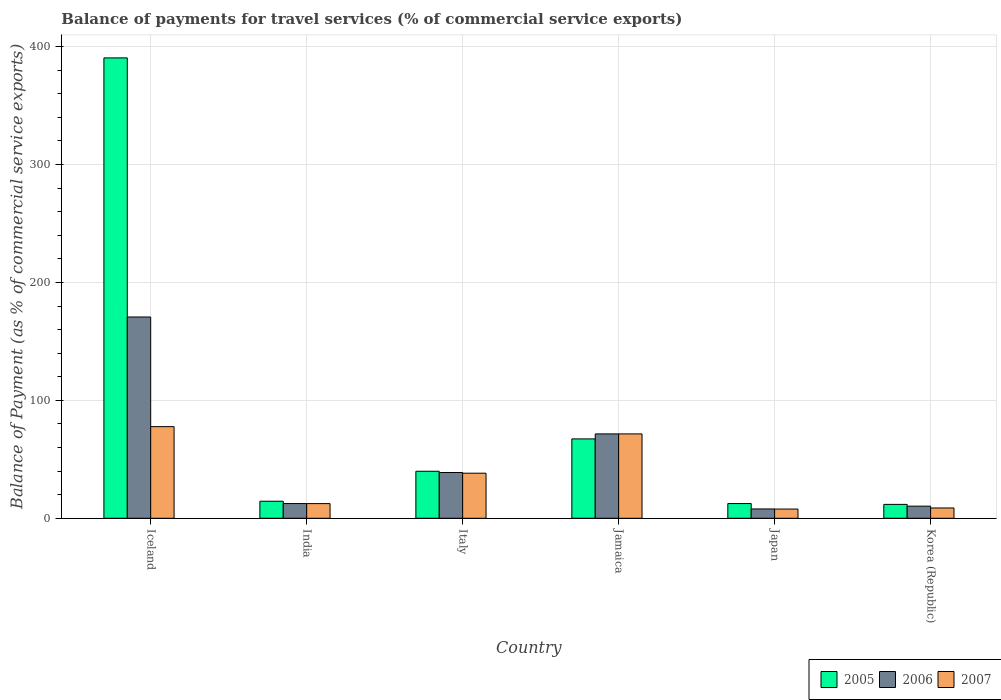How many different coloured bars are there?
Give a very brief answer. 3. Are the number of bars per tick equal to the number of legend labels?
Ensure brevity in your answer.  Yes. How many bars are there on the 2nd tick from the left?
Offer a terse response. 3. What is the label of the 3rd group of bars from the left?
Ensure brevity in your answer.  Italy. In how many cases, is the number of bars for a given country not equal to the number of legend labels?
Provide a succinct answer. 0. What is the balance of payments for travel services in 2005 in Italy?
Give a very brief answer. 39.87. Across all countries, what is the maximum balance of payments for travel services in 2005?
Your response must be concise. 390.42. Across all countries, what is the minimum balance of payments for travel services in 2007?
Your answer should be very brief. 7.82. In which country was the balance of payments for travel services in 2005 maximum?
Your answer should be very brief. Iceland. What is the total balance of payments for travel services in 2006 in the graph?
Provide a succinct answer. 311.73. What is the difference between the balance of payments for travel services in 2007 in Italy and that in Korea (Republic)?
Keep it short and to the point. 29.49. What is the difference between the balance of payments for travel services in 2006 in Iceland and the balance of payments for travel services in 2005 in Japan?
Ensure brevity in your answer.  158.22. What is the average balance of payments for travel services in 2005 per country?
Provide a short and direct response. 89.38. What is the difference between the balance of payments for travel services of/in 2005 and balance of payments for travel services of/in 2007 in Korea (Republic)?
Your answer should be very brief. 3.04. In how many countries, is the balance of payments for travel services in 2007 greater than 360 %?
Offer a terse response. 0. What is the ratio of the balance of payments for travel services in 2005 in India to that in Korea (Republic)?
Your answer should be compact. 1.23. What is the difference between the highest and the second highest balance of payments for travel services in 2005?
Offer a very short reply. -323.11. What is the difference between the highest and the lowest balance of payments for travel services in 2007?
Your answer should be compact. 69.9. In how many countries, is the balance of payments for travel services in 2007 greater than the average balance of payments for travel services in 2007 taken over all countries?
Make the answer very short. 3. Is the sum of the balance of payments for travel services in 2007 in Iceland and Italy greater than the maximum balance of payments for travel services in 2005 across all countries?
Give a very brief answer. No. What does the 1st bar from the left in Jamaica represents?
Ensure brevity in your answer.  2005. What does the 3rd bar from the right in Japan represents?
Provide a succinct answer. 2005. How many countries are there in the graph?
Your response must be concise. 6. What is the difference between two consecutive major ticks on the Y-axis?
Keep it short and to the point. 100. Are the values on the major ticks of Y-axis written in scientific E-notation?
Offer a very short reply. No. Does the graph contain any zero values?
Your answer should be compact. No. How are the legend labels stacked?
Provide a short and direct response. Horizontal. What is the title of the graph?
Provide a succinct answer. Balance of payments for travel services (% of commercial service exports). Does "1992" appear as one of the legend labels in the graph?
Offer a terse response. No. What is the label or title of the Y-axis?
Your response must be concise. Balance of Payment (as % of commercial service exports). What is the Balance of Payment (as % of commercial service exports) of 2005 in Iceland?
Your answer should be compact. 390.42. What is the Balance of Payment (as % of commercial service exports) in 2006 in Iceland?
Provide a short and direct response. 170.69. What is the Balance of Payment (as % of commercial service exports) of 2007 in Iceland?
Your answer should be compact. 77.72. What is the Balance of Payment (as % of commercial service exports) in 2005 in India?
Offer a very short reply. 14.45. What is the Balance of Payment (as % of commercial service exports) of 2006 in India?
Provide a succinct answer. 12.48. What is the Balance of Payment (as % of commercial service exports) of 2007 in India?
Give a very brief answer. 12.44. What is the Balance of Payment (as % of commercial service exports) of 2005 in Italy?
Make the answer very short. 39.87. What is the Balance of Payment (as % of commercial service exports) in 2006 in Italy?
Offer a terse response. 38.81. What is the Balance of Payment (as % of commercial service exports) in 2007 in Italy?
Ensure brevity in your answer.  38.22. What is the Balance of Payment (as % of commercial service exports) of 2005 in Jamaica?
Keep it short and to the point. 67.31. What is the Balance of Payment (as % of commercial service exports) of 2006 in Jamaica?
Provide a short and direct response. 71.55. What is the Balance of Payment (as % of commercial service exports) in 2007 in Jamaica?
Ensure brevity in your answer.  71.55. What is the Balance of Payment (as % of commercial service exports) in 2005 in Japan?
Provide a short and direct response. 12.48. What is the Balance of Payment (as % of commercial service exports) in 2006 in Japan?
Your answer should be compact. 7.9. What is the Balance of Payment (as % of commercial service exports) in 2007 in Japan?
Your answer should be compact. 7.82. What is the Balance of Payment (as % of commercial service exports) of 2005 in Korea (Republic)?
Provide a short and direct response. 11.77. What is the Balance of Payment (as % of commercial service exports) in 2006 in Korea (Republic)?
Your response must be concise. 10.28. What is the Balance of Payment (as % of commercial service exports) of 2007 in Korea (Republic)?
Ensure brevity in your answer.  8.73. Across all countries, what is the maximum Balance of Payment (as % of commercial service exports) of 2005?
Provide a short and direct response. 390.42. Across all countries, what is the maximum Balance of Payment (as % of commercial service exports) of 2006?
Offer a terse response. 170.69. Across all countries, what is the maximum Balance of Payment (as % of commercial service exports) in 2007?
Your response must be concise. 77.72. Across all countries, what is the minimum Balance of Payment (as % of commercial service exports) of 2005?
Your answer should be compact. 11.77. Across all countries, what is the minimum Balance of Payment (as % of commercial service exports) of 2006?
Your response must be concise. 7.9. Across all countries, what is the minimum Balance of Payment (as % of commercial service exports) in 2007?
Your response must be concise. 7.82. What is the total Balance of Payment (as % of commercial service exports) in 2005 in the graph?
Give a very brief answer. 536.31. What is the total Balance of Payment (as % of commercial service exports) in 2006 in the graph?
Your response must be concise. 311.73. What is the total Balance of Payment (as % of commercial service exports) of 2007 in the graph?
Keep it short and to the point. 216.49. What is the difference between the Balance of Payment (as % of commercial service exports) of 2005 in Iceland and that in India?
Provide a succinct answer. 375.97. What is the difference between the Balance of Payment (as % of commercial service exports) of 2006 in Iceland and that in India?
Your answer should be very brief. 158.21. What is the difference between the Balance of Payment (as % of commercial service exports) of 2007 in Iceland and that in India?
Keep it short and to the point. 65.28. What is the difference between the Balance of Payment (as % of commercial service exports) of 2005 in Iceland and that in Italy?
Make the answer very short. 350.55. What is the difference between the Balance of Payment (as % of commercial service exports) of 2006 in Iceland and that in Italy?
Provide a short and direct response. 131.88. What is the difference between the Balance of Payment (as % of commercial service exports) of 2007 in Iceland and that in Italy?
Offer a very short reply. 39.49. What is the difference between the Balance of Payment (as % of commercial service exports) of 2005 in Iceland and that in Jamaica?
Offer a terse response. 323.11. What is the difference between the Balance of Payment (as % of commercial service exports) of 2006 in Iceland and that in Jamaica?
Make the answer very short. 99.14. What is the difference between the Balance of Payment (as % of commercial service exports) of 2007 in Iceland and that in Jamaica?
Your answer should be compact. 6.17. What is the difference between the Balance of Payment (as % of commercial service exports) of 2005 in Iceland and that in Japan?
Keep it short and to the point. 377.94. What is the difference between the Balance of Payment (as % of commercial service exports) in 2006 in Iceland and that in Japan?
Offer a very short reply. 162.79. What is the difference between the Balance of Payment (as % of commercial service exports) in 2007 in Iceland and that in Japan?
Ensure brevity in your answer.  69.9. What is the difference between the Balance of Payment (as % of commercial service exports) in 2005 in Iceland and that in Korea (Republic)?
Offer a very short reply. 378.65. What is the difference between the Balance of Payment (as % of commercial service exports) in 2006 in Iceland and that in Korea (Republic)?
Give a very brief answer. 160.42. What is the difference between the Balance of Payment (as % of commercial service exports) of 2007 in Iceland and that in Korea (Republic)?
Provide a short and direct response. 68.99. What is the difference between the Balance of Payment (as % of commercial service exports) of 2005 in India and that in Italy?
Provide a short and direct response. -25.42. What is the difference between the Balance of Payment (as % of commercial service exports) of 2006 in India and that in Italy?
Your response must be concise. -26.33. What is the difference between the Balance of Payment (as % of commercial service exports) of 2007 in India and that in Italy?
Your answer should be very brief. -25.78. What is the difference between the Balance of Payment (as % of commercial service exports) of 2005 in India and that in Jamaica?
Provide a short and direct response. -52.86. What is the difference between the Balance of Payment (as % of commercial service exports) of 2006 in India and that in Jamaica?
Your response must be concise. -59.07. What is the difference between the Balance of Payment (as % of commercial service exports) of 2007 in India and that in Jamaica?
Provide a short and direct response. -59.11. What is the difference between the Balance of Payment (as % of commercial service exports) of 2005 in India and that in Japan?
Offer a terse response. 1.97. What is the difference between the Balance of Payment (as % of commercial service exports) in 2006 in India and that in Japan?
Offer a terse response. 4.58. What is the difference between the Balance of Payment (as % of commercial service exports) of 2007 in India and that in Japan?
Keep it short and to the point. 4.62. What is the difference between the Balance of Payment (as % of commercial service exports) of 2005 in India and that in Korea (Republic)?
Make the answer very short. 2.68. What is the difference between the Balance of Payment (as % of commercial service exports) in 2006 in India and that in Korea (Republic)?
Make the answer very short. 2.2. What is the difference between the Balance of Payment (as % of commercial service exports) of 2007 in India and that in Korea (Republic)?
Provide a succinct answer. 3.71. What is the difference between the Balance of Payment (as % of commercial service exports) in 2005 in Italy and that in Jamaica?
Keep it short and to the point. -27.44. What is the difference between the Balance of Payment (as % of commercial service exports) in 2006 in Italy and that in Jamaica?
Make the answer very short. -32.74. What is the difference between the Balance of Payment (as % of commercial service exports) in 2007 in Italy and that in Jamaica?
Provide a succinct answer. -33.32. What is the difference between the Balance of Payment (as % of commercial service exports) in 2005 in Italy and that in Japan?
Give a very brief answer. 27.4. What is the difference between the Balance of Payment (as % of commercial service exports) in 2006 in Italy and that in Japan?
Your answer should be compact. 30.91. What is the difference between the Balance of Payment (as % of commercial service exports) of 2007 in Italy and that in Japan?
Your response must be concise. 30.41. What is the difference between the Balance of Payment (as % of commercial service exports) of 2005 in Italy and that in Korea (Republic)?
Your response must be concise. 28.1. What is the difference between the Balance of Payment (as % of commercial service exports) in 2006 in Italy and that in Korea (Republic)?
Offer a very short reply. 28.54. What is the difference between the Balance of Payment (as % of commercial service exports) of 2007 in Italy and that in Korea (Republic)?
Ensure brevity in your answer.  29.49. What is the difference between the Balance of Payment (as % of commercial service exports) of 2005 in Jamaica and that in Japan?
Make the answer very short. 54.83. What is the difference between the Balance of Payment (as % of commercial service exports) of 2006 in Jamaica and that in Japan?
Keep it short and to the point. 63.65. What is the difference between the Balance of Payment (as % of commercial service exports) in 2007 in Jamaica and that in Japan?
Make the answer very short. 63.73. What is the difference between the Balance of Payment (as % of commercial service exports) in 2005 in Jamaica and that in Korea (Republic)?
Make the answer very short. 55.54. What is the difference between the Balance of Payment (as % of commercial service exports) in 2006 in Jamaica and that in Korea (Republic)?
Make the answer very short. 61.28. What is the difference between the Balance of Payment (as % of commercial service exports) in 2007 in Jamaica and that in Korea (Republic)?
Your answer should be compact. 62.82. What is the difference between the Balance of Payment (as % of commercial service exports) in 2005 in Japan and that in Korea (Republic)?
Keep it short and to the point. 0.7. What is the difference between the Balance of Payment (as % of commercial service exports) of 2006 in Japan and that in Korea (Republic)?
Your response must be concise. -2.38. What is the difference between the Balance of Payment (as % of commercial service exports) in 2007 in Japan and that in Korea (Republic)?
Ensure brevity in your answer.  -0.91. What is the difference between the Balance of Payment (as % of commercial service exports) in 2005 in Iceland and the Balance of Payment (as % of commercial service exports) in 2006 in India?
Provide a succinct answer. 377.94. What is the difference between the Balance of Payment (as % of commercial service exports) of 2005 in Iceland and the Balance of Payment (as % of commercial service exports) of 2007 in India?
Offer a terse response. 377.98. What is the difference between the Balance of Payment (as % of commercial service exports) in 2006 in Iceland and the Balance of Payment (as % of commercial service exports) in 2007 in India?
Your response must be concise. 158.25. What is the difference between the Balance of Payment (as % of commercial service exports) in 2005 in Iceland and the Balance of Payment (as % of commercial service exports) in 2006 in Italy?
Give a very brief answer. 351.61. What is the difference between the Balance of Payment (as % of commercial service exports) in 2005 in Iceland and the Balance of Payment (as % of commercial service exports) in 2007 in Italy?
Give a very brief answer. 352.2. What is the difference between the Balance of Payment (as % of commercial service exports) in 2006 in Iceland and the Balance of Payment (as % of commercial service exports) in 2007 in Italy?
Provide a succinct answer. 132.47. What is the difference between the Balance of Payment (as % of commercial service exports) of 2005 in Iceland and the Balance of Payment (as % of commercial service exports) of 2006 in Jamaica?
Your answer should be compact. 318.87. What is the difference between the Balance of Payment (as % of commercial service exports) in 2005 in Iceland and the Balance of Payment (as % of commercial service exports) in 2007 in Jamaica?
Keep it short and to the point. 318.87. What is the difference between the Balance of Payment (as % of commercial service exports) in 2006 in Iceland and the Balance of Payment (as % of commercial service exports) in 2007 in Jamaica?
Ensure brevity in your answer.  99.15. What is the difference between the Balance of Payment (as % of commercial service exports) of 2005 in Iceland and the Balance of Payment (as % of commercial service exports) of 2006 in Japan?
Make the answer very short. 382.52. What is the difference between the Balance of Payment (as % of commercial service exports) of 2005 in Iceland and the Balance of Payment (as % of commercial service exports) of 2007 in Japan?
Give a very brief answer. 382.6. What is the difference between the Balance of Payment (as % of commercial service exports) of 2006 in Iceland and the Balance of Payment (as % of commercial service exports) of 2007 in Japan?
Give a very brief answer. 162.88. What is the difference between the Balance of Payment (as % of commercial service exports) of 2005 in Iceland and the Balance of Payment (as % of commercial service exports) of 2006 in Korea (Republic)?
Your answer should be compact. 380.14. What is the difference between the Balance of Payment (as % of commercial service exports) in 2005 in Iceland and the Balance of Payment (as % of commercial service exports) in 2007 in Korea (Republic)?
Ensure brevity in your answer.  381.69. What is the difference between the Balance of Payment (as % of commercial service exports) of 2006 in Iceland and the Balance of Payment (as % of commercial service exports) of 2007 in Korea (Republic)?
Your answer should be very brief. 161.96. What is the difference between the Balance of Payment (as % of commercial service exports) of 2005 in India and the Balance of Payment (as % of commercial service exports) of 2006 in Italy?
Give a very brief answer. -24.36. What is the difference between the Balance of Payment (as % of commercial service exports) in 2005 in India and the Balance of Payment (as % of commercial service exports) in 2007 in Italy?
Offer a terse response. -23.77. What is the difference between the Balance of Payment (as % of commercial service exports) of 2006 in India and the Balance of Payment (as % of commercial service exports) of 2007 in Italy?
Make the answer very short. -25.74. What is the difference between the Balance of Payment (as % of commercial service exports) of 2005 in India and the Balance of Payment (as % of commercial service exports) of 2006 in Jamaica?
Ensure brevity in your answer.  -57.1. What is the difference between the Balance of Payment (as % of commercial service exports) of 2005 in India and the Balance of Payment (as % of commercial service exports) of 2007 in Jamaica?
Make the answer very short. -57.1. What is the difference between the Balance of Payment (as % of commercial service exports) in 2006 in India and the Balance of Payment (as % of commercial service exports) in 2007 in Jamaica?
Your response must be concise. -59.07. What is the difference between the Balance of Payment (as % of commercial service exports) in 2005 in India and the Balance of Payment (as % of commercial service exports) in 2006 in Japan?
Provide a succinct answer. 6.55. What is the difference between the Balance of Payment (as % of commercial service exports) in 2005 in India and the Balance of Payment (as % of commercial service exports) in 2007 in Japan?
Keep it short and to the point. 6.63. What is the difference between the Balance of Payment (as % of commercial service exports) in 2006 in India and the Balance of Payment (as % of commercial service exports) in 2007 in Japan?
Make the answer very short. 4.66. What is the difference between the Balance of Payment (as % of commercial service exports) of 2005 in India and the Balance of Payment (as % of commercial service exports) of 2006 in Korea (Republic)?
Keep it short and to the point. 4.17. What is the difference between the Balance of Payment (as % of commercial service exports) in 2005 in India and the Balance of Payment (as % of commercial service exports) in 2007 in Korea (Republic)?
Ensure brevity in your answer.  5.72. What is the difference between the Balance of Payment (as % of commercial service exports) of 2006 in India and the Balance of Payment (as % of commercial service exports) of 2007 in Korea (Republic)?
Your answer should be compact. 3.75. What is the difference between the Balance of Payment (as % of commercial service exports) of 2005 in Italy and the Balance of Payment (as % of commercial service exports) of 2006 in Jamaica?
Offer a terse response. -31.68. What is the difference between the Balance of Payment (as % of commercial service exports) of 2005 in Italy and the Balance of Payment (as % of commercial service exports) of 2007 in Jamaica?
Give a very brief answer. -31.68. What is the difference between the Balance of Payment (as % of commercial service exports) in 2006 in Italy and the Balance of Payment (as % of commercial service exports) in 2007 in Jamaica?
Provide a succinct answer. -32.73. What is the difference between the Balance of Payment (as % of commercial service exports) of 2005 in Italy and the Balance of Payment (as % of commercial service exports) of 2006 in Japan?
Keep it short and to the point. 31.97. What is the difference between the Balance of Payment (as % of commercial service exports) in 2005 in Italy and the Balance of Payment (as % of commercial service exports) in 2007 in Japan?
Your answer should be compact. 32.05. What is the difference between the Balance of Payment (as % of commercial service exports) of 2006 in Italy and the Balance of Payment (as % of commercial service exports) of 2007 in Japan?
Give a very brief answer. 31. What is the difference between the Balance of Payment (as % of commercial service exports) in 2005 in Italy and the Balance of Payment (as % of commercial service exports) in 2006 in Korea (Republic)?
Ensure brevity in your answer.  29.59. What is the difference between the Balance of Payment (as % of commercial service exports) of 2005 in Italy and the Balance of Payment (as % of commercial service exports) of 2007 in Korea (Republic)?
Keep it short and to the point. 31.14. What is the difference between the Balance of Payment (as % of commercial service exports) of 2006 in Italy and the Balance of Payment (as % of commercial service exports) of 2007 in Korea (Republic)?
Offer a very short reply. 30.08. What is the difference between the Balance of Payment (as % of commercial service exports) of 2005 in Jamaica and the Balance of Payment (as % of commercial service exports) of 2006 in Japan?
Provide a succinct answer. 59.41. What is the difference between the Balance of Payment (as % of commercial service exports) of 2005 in Jamaica and the Balance of Payment (as % of commercial service exports) of 2007 in Japan?
Keep it short and to the point. 59.49. What is the difference between the Balance of Payment (as % of commercial service exports) in 2006 in Jamaica and the Balance of Payment (as % of commercial service exports) in 2007 in Japan?
Your answer should be very brief. 63.74. What is the difference between the Balance of Payment (as % of commercial service exports) of 2005 in Jamaica and the Balance of Payment (as % of commercial service exports) of 2006 in Korea (Republic)?
Offer a very short reply. 57.03. What is the difference between the Balance of Payment (as % of commercial service exports) in 2005 in Jamaica and the Balance of Payment (as % of commercial service exports) in 2007 in Korea (Republic)?
Your response must be concise. 58.58. What is the difference between the Balance of Payment (as % of commercial service exports) of 2006 in Jamaica and the Balance of Payment (as % of commercial service exports) of 2007 in Korea (Republic)?
Your response must be concise. 62.82. What is the difference between the Balance of Payment (as % of commercial service exports) of 2005 in Japan and the Balance of Payment (as % of commercial service exports) of 2006 in Korea (Republic)?
Your answer should be compact. 2.2. What is the difference between the Balance of Payment (as % of commercial service exports) of 2005 in Japan and the Balance of Payment (as % of commercial service exports) of 2007 in Korea (Republic)?
Your answer should be compact. 3.74. What is the difference between the Balance of Payment (as % of commercial service exports) in 2006 in Japan and the Balance of Payment (as % of commercial service exports) in 2007 in Korea (Republic)?
Your answer should be very brief. -0.83. What is the average Balance of Payment (as % of commercial service exports) in 2005 per country?
Offer a very short reply. 89.38. What is the average Balance of Payment (as % of commercial service exports) of 2006 per country?
Your answer should be compact. 51.95. What is the average Balance of Payment (as % of commercial service exports) of 2007 per country?
Provide a succinct answer. 36.08. What is the difference between the Balance of Payment (as % of commercial service exports) in 2005 and Balance of Payment (as % of commercial service exports) in 2006 in Iceland?
Provide a succinct answer. 219.73. What is the difference between the Balance of Payment (as % of commercial service exports) of 2005 and Balance of Payment (as % of commercial service exports) of 2007 in Iceland?
Provide a short and direct response. 312.7. What is the difference between the Balance of Payment (as % of commercial service exports) in 2006 and Balance of Payment (as % of commercial service exports) in 2007 in Iceland?
Your answer should be compact. 92.98. What is the difference between the Balance of Payment (as % of commercial service exports) of 2005 and Balance of Payment (as % of commercial service exports) of 2006 in India?
Ensure brevity in your answer.  1.97. What is the difference between the Balance of Payment (as % of commercial service exports) of 2005 and Balance of Payment (as % of commercial service exports) of 2007 in India?
Provide a short and direct response. 2.01. What is the difference between the Balance of Payment (as % of commercial service exports) of 2006 and Balance of Payment (as % of commercial service exports) of 2007 in India?
Your response must be concise. 0.04. What is the difference between the Balance of Payment (as % of commercial service exports) in 2005 and Balance of Payment (as % of commercial service exports) in 2006 in Italy?
Offer a very short reply. 1.06. What is the difference between the Balance of Payment (as % of commercial service exports) of 2005 and Balance of Payment (as % of commercial service exports) of 2007 in Italy?
Provide a succinct answer. 1.65. What is the difference between the Balance of Payment (as % of commercial service exports) of 2006 and Balance of Payment (as % of commercial service exports) of 2007 in Italy?
Make the answer very short. 0.59. What is the difference between the Balance of Payment (as % of commercial service exports) in 2005 and Balance of Payment (as % of commercial service exports) in 2006 in Jamaica?
Provide a short and direct response. -4.24. What is the difference between the Balance of Payment (as % of commercial service exports) in 2005 and Balance of Payment (as % of commercial service exports) in 2007 in Jamaica?
Offer a very short reply. -4.24. What is the difference between the Balance of Payment (as % of commercial service exports) of 2006 and Balance of Payment (as % of commercial service exports) of 2007 in Jamaica?
Offer a very short reply. 0.01. What is the difference between the Balance of Payment (as % of commercial service exports) of 2005 and Balance of Payment (as % of commercial service exports) of 2006 in Japan?
Give a very brief answer. 4.57. What is the difference between the Balance of Payment (as % of commercial service exports) of 2005 and Balance of Payment (as % of commercial service exports) of 2007 in Japan?
Offer a very short reply. 4.66. What is the difference between the Balance of Payment (as % of commercial service exports) in 2006 and Balance of Payment (as % of commercial service exports) in 2007 in Japan?
Your answer should be compact. 0.08. What is the difference between the Balance of Payment (as % of commercial service exports) in 2005 and Balance of Payment (as % of commercial service exports) in 2006 in Korea (Republic)?
Your response must be concise. 1.49. What is the difference between the Balance of Payment (as % of commercial service exports) in 2005 and Balance of Payment (as % of commercial service exports) in 2007 in Korea (Republic)?
Make the answer very short. 3.04. What is the difference between the Balance of Payment (as % of commercial service exports) of 2006 and Balance of Payment (as % of commercial service exports) of 2007 in Korea (Republic)?
Your response must be concise. 1.54. What is the ratio of the Balance of Payment (as % of commercial service exports) of 2005 in Iceland to that in India?
Give a very brief answer. 27.02. What is the ratio of the Balance of Payment (as % of commercial service exports) in 2006 in Iceland to that in India?
Keep it short and to the point. 13.67. What is the ratio of the Balance of Payment (as % of commercial service exports) in 2007 in Iceland to that in India?
Give a very brief answer. 6.25. What is the ratio of the Balance of Payment (as % of commercial service exports) of 2005 in Iceland to that in Italy?
Your answer should be very brief. 9.79. What is the ratio of the Balance of Payment (as % of commercial service exports) of 2006 in Iceland to that in Italy?
Your answer should be compact. 4.4. What is the ratio of the Balance of Payment (as % of commercial service exports) of 2007 in Iceland to that in Italy?
Your answer should be very brief. 2.03. What is the ratio of the Balance of Payment (as % of commercial service exports) in 2005 in Iceland to that in Jamaica?
Your answer should be very brief. 5.8. What is the ratio of the Balance of Payment (as % of commercial service exports) of 2006 in Iceland to that in Jamaica?
Provide a short and direct response. 2.39. What is the ratio of the Balance of Payment (as % of commercial service exports) of 2007 in Iceland to that in Jamaica?
Provide a short and direct response. 1.09. What is the ratio of the Balance of Payment (as % of commercial service exports) in 2005 in Iceland to that in Japan?
Your response must be concise. 31.29. What is the ratio of the Balance of Payment (as % of commercial service exports) in 2006 in Iceland to that in Japan?
Keep it short and to the point. 21.6. What is the ratio of the Balance of Payment (as % of commercial service exports) of 2007 in Iceland to that in Japan?
Provide a succinct answer. 9.94. What is the ratio of the Balance of Payment (as % of commercial service exports) of 2005 in Iceland to that in Korea (Republic)?
Offer a very short reply. 33.16. What is the ratio of the Balance of Payment (as % of commercial service exports) in 2006 in Iceland to that in Korea (Republic)?
Make the answer very short. 16.61. What is the ratio of the Balance of Payment (as % of commercial service exports) of 2007 in Iceland to that in Korea (Republic)?
Keep it short and to the point. 8.9. What is the ratio of the Balance of Payment (as % of commercial service exports) of 2005 in India to that in Italy?
Ensure brevity in your answer.  0.36. What is the ratio of the Balance of Payment (as % of commercial service exports) in 2006 in India to that in Italy?
Ensure brevity in your answer.  0.32. What is the ratio of the Balance of Payment (as % of commercial service exports) of 2007 in India to that in Italy?
Your response must be concise. 0.33. What is the ratio of the Balance of Payment (as % of commercial service exports) in 2005 in India to that in Jamaica?
Provide a short and direct response. 0.21. What is the ratio of the Balance of Payment (as % of commercial service exports) of 2006 in India to that in Jamaica?
Your answer should be compact. 0.17. What is the ratio of the Balance of Payment (as % of commercial service exports) of 2007 in India to that in Jamaica?
Your response must be concise. 0.17. What is the ratio of the Balance of Payment (as % of commercial service exports) in 2005 in India to that in Japan?
Give a very brief answer. 1.16. What is the ratio of the Balance of Payment (as % of commercial service exports) in 2006 in India to that in Japan?
Your answer should be very brief. 1.58. What is the ratio of the Balance of Payment (as % of commercial service exports) of 2007 in India to that in Japan?
Give a very brief answer. 1.59. What is the ratio of the Balance of Payment (as % of commercial service exports) in 2005 in India to that in Korea (Republic)?
Offer a very short reply. 1.23. What is the ratio of the Balance of Payment (as % of commercial service exports) in 2006 in India to that in Korea (Republic)?
Keep it short and to the point. 1.21. What is the ratio of the Balance of Payment (as % of commercial service exports) in 2007 in India to that in Korea (Republic)?
Give a very brief answer. 1.42. What is the ratio of the Balance of Payment (as % of commercial service exports) in 2005 in Italy to that in Jamaica?
Make the answer very short. 0.59. What is the ratio of the Balance of Payment (as % of commercial service exports) in 2006 in Italy to that in Jamaica?
Your response must be concise. 0.54. What is the ratio of the Balance of Payment (as % of commercial service exports) of 2007 in Italy to that in Jamaica?
Offer a terse response. 0.53. What is the ratio of the Balance of Payment (as % of commercial service exports) of 2005 in Italy to that in Japan?
Offer a terse response. 3.2. What is the ratio of the Balance of Payment (as % of commercial service exports) of 2006 in Italy to that in Japan?
Your response must be concise. 4.91. What is the ratio of the Balance of Payment (as % of commercial service exports) of 2007 in Italy to that in Japan?
Offer a terse response. 4.89. What is the ratio of the Balance of Payment (as % of commercial service exports) in 2005 in Italy to that in Korea (Republic)?
Make the answer very short. 3.39. What is the ratio of the Balance of Payment (as % of commercial service exports) in 2006 in Italy to that in Korea (Republic)?
Make the answer very short. 3.78. What is the ratio of the Balance of Payment (as % of commercial service exports) of 2007 in Italy to that in Korea (Republic)?
Your answer should be very brief. 4.38. What is the ratio of the Balance of Payment (as % of commercial service exports) in 2005 in Jamaica to that in Japan?
Your response must be concise. 5.39. What is the ratio of the Balance of Payment (as % of commercial service exports) in 2006 in Jamaica to that in Japan?
Your answer should be very brief. 9.05. What is the ratio of the Balance of Payment (as % of commercial service exports) of 2007 in Jamaica to that in Japan?
Offer a very short reply. 9.15. What is the ratio of the Balance of Payment (as % of commercial service exports) in 2005 in Jamaica to that in Korea (Republic)?
Provide a succinct answer. 5.72. What is the ratio of the Balance of Payment (as % of commercial service exports) of 2006 in Jamaica to that in Korea (Republic)?
Provide a succinct answer. 6.96. What is the ratio of the Balance of Payment (as % of commercial service exports) of 2007 in Jamaica to that in Korea (Republic)?
Ensure brevity in your answer.  8.19. What is the ratio of the Balance of Payment (as % of commercial service exports) in 2005 in Japan to that in Korea (Republic)?
Make the answer very short. 1.06. What is the ratio of the Balance of Payment (as % of commercial service exports) of 2006 in Japan to that in Korea (Republic)?
Offer a terse response. 0.77. What is the ratio of the Balance of Payment (as % of commercial service exports) of 2007 in Japan to that in Korea (Republic)?
Offer a very short reply. 0.9. What is the difference between the highest and the second highest Balance of Payment (as % of commercial service exports) in 2005?
Provide a short and direct response. 323.11. What is the difference between the highest and the second highest Balance of Payment (as % of commercial service exports) in 2006?
Keep it short and to the point. 99.14. What is the difference between the highest and the second highest Balance of Payment (as % of commercial service exports) in 2007?
Provide a succinct answer. 6.17. What is the difference between the highest and the lowest Balance of Payment (as % of commercial service exports) of 2005?
Offer a very short reply. 378.65. What is the difference between the highest and the lowest Balance of Payment (as % of commercial service exports) in 2006?
Your answer should be compact. 162.79. What is the difference between the highest and the lowest Balance of Payment (as % of commercial service exports) of 2007?
Offer a very short reply. 69.9. 